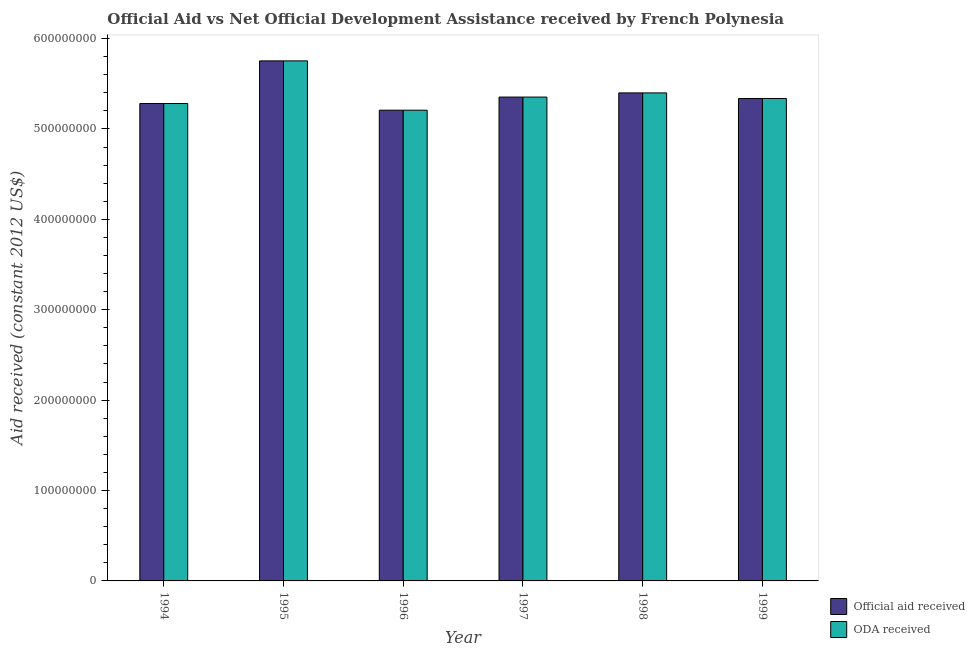How many different coloured bars are there?
Your answer should be very brief. 2. Are the number of bars per tick equal to the number of legend labels?
Your response must be concise. Yes. How many bars are there on the 1st tick from the right?
Your answer should be very brief. 2. What is the label of the 5th group of bars from the left?
Make the answer very short. 1998. What is the oda received in 1994?
Make the answer very short. 5.28e+08. Across all years, what is the maximum oda received?
Provide a succinct answer. 5.75e+08. Across all years, what is the minimum official aid received?
Your answer should be compact. 5.21e+08. In which year was the official aid received minimum?
Provide a succinct answer. 1996. What is the total oda received in the graph?
Offer a very short reply. 3.23e+09. What is the difference between the official aid received in 1998 and that in 1999?
Ensure brevity in your answer.  6.19e+06. What is the difference between the oda received in 1995 and the official aid received in 1998?
Provide a succinct answer. 3.54e+07. What is the average oda received per year?
Make the answer very short. 5.39e+08. In the year 1995, what is the difference between the official aid received and oda received?
Your answer should be very brief. 0. In how many years, is the oda received greater than 80000000 US$?
Offer a terse response. 6. What is the ratio of the oda received in 1998 to that in 1999?
Offer a terse response. 1.01. Is the oda received in 1998 less than that in 1999?
Your response must be concise. No. Is the difference between the official aid received in 1997 and 1999 greater than the difference between the oda received in 1997 and 1999?
Your response must be concise. No. What is the difference between the highest and the second highest official aid received?
Keep it short and to the point. 3.54e+07. What is the difference between the highest and the lowest official aid received?
Give a very brief answer. 5.46e+07. Is the sum of the oda received in 1996 and 1998 greater than the maximum official aid received across all years?
Your response must be concise. Yes. What does the 1st bar from the left in 1999 represents?
Your answer should be compact. Official aid received. What does the 1st bar from the right in 1996 represents?
Ensure brevity in your answer.  ODA received. Are all the bars in the graph horizontal?
Keep it short and to the point. No. How many years are there in the graph?
Your answer should be compact. 6. What is the difference between two consecutive major ticks on the Y-axis?
Offer a very short reply. 1.00e+08. Are the values on the major ticks of Y-axis written in scientific E-notation?
Provide a succinct answer. No. Does the graph contain grids?
Keep it short and to the point. No. How many legend labels are there?
Offer a very short reply. 2. How are the legend labels stacked?
Your response must be concise. Vertical. What is the title of the graph?
Your response must be concise. Official Aid vs Net Official Development Assistance received by French Polynesia . What is the label or title of the Y-axis?
Offer a very short reply. Aid received (constant 2012 US$). What is the Aid received (constant 2012 US$) of Official aid received in 1994?
Your response must be concise. 5.28e+08. What is the Aid received (constant 2012 US$) of ODA received in 1994?
Offer a terse response. 5.28e+08. What is the Aid received (constant 2012 US$) in Official aid received in 1995?
Give a very brief answer. 5.75e+08. What is the Aid received (constant 2012 US$) of ODA received in 1995?
Provide a short and direct response. 5.75e+08. What is the Aid received (constant 2012 US$) of Official aid received in 1996?
Ensure brevity in your answer.  5.21e+08. What is the Aid received (constant 2012 US$) in ODA received in 1996?
Keep it short and to the point. 5.21e+08. What is the Aid received (constant 2012 US$) in Official aid received in 1997?
Your answer should be compact. 5.35e+08. What is the Aid received (constant 2012 US$) in ODA received in 1997?
Provide a succinct answer. 5.35e+08. What is the Aid received (constant 2012 US$) in Official aid received in 1998?
Provide a succinct answer. 5.40e+08. What is the Aid received (constant 2012 US$) of ODA received in 1998?
Provide a short and direct response. 5.40e+08. What is the Aid received (constant 2012 US$) of Official aid received in 1999?
Provide a succinct answer. 5.34e+08. What is the Aid received (constant 2012 US$) of ODA received in 1999?
Offer a very short reply. 5.34e+08. Across all years, what is the maximum Aid received (constant 2012 US$) of Official aid received?
Your answer should be compact. 5.75e+08. Across all years, what is the maximum Aid received (constant 2012 US$) in ODA received?
Offer a very short reply. 5.75e+08. Across all years, what is the minimum Aid received (constant 2012 US$) in Official aid received?
Give a very brief answer. 5.21e+08. Across all years, what is the minimum Aid received (constant 2012 US$) in ODA received?
Your response must be concise. 5.21e+08. What is the total Aid received (constant 2012 US$) in Official aid received in the graph?
Ensure brevity in your answer.  3.23e+09. What is the total Aid received (constant 2012 US$) of ODA received in the graph?
Offer a terse response. 3.23e+09. What is the difference between the Aid received (constant 2012 US$) of Official aid received in 1994 and that in 1995?
Your answer should be very brief. -4.72e+07. What is the difference between the Aid received (constant 2012 US$) in ODA received in 1994 and that in 1995?
Offer a terse response. -4.72e+07. What is the difference between the Aid received (constant 2012 US$) in Official aid received in 1994 and that in 1996?
Your answer should be very brief. 7.39e+06. What is the difference between the Aid received (constant 2012 US$) of ODA received in 1994 and that in 1996?
Provide a short and direct response. 7.39e+06. What is the difference between the Aid received (constant 2012 US$) in Official aid received in 1994 and that in 1997?
Offer a terse response. -7.14e+06. What is the difference between the Aid received (constant 2012 US$) in ODA received in 1994 and that in 1997?
Ensure brevity in your answer.  -7.14e+06. What is the difference between the Aid received (constant 2012 US$) of Official aid received in 1994 and that in 1998?
Ensure brevity in your answer.  -1.18e+07. What is the difference between the Aid received (constant 2012 US$) of ODA received in 1994 and that in 1998?
Provide a short and direct response. -1.18e+07. What is the difference between the Aid received (constant 2012 US$) of Official aid received in 1994 and that in 1999?
Make the answer very short. -5.56e+06. What is the difference between the Aid received (constant 2012 US$) in ODA received in 1994 and that in 1999?
Give a very brief answer. -5.56e+06. What is the difference between the Aid received (constant 2012 US$) of Official aid received in 1995 and that in 1996?
Offer a terse response. 5.46e+07. What is the difference between the Aid received (constant 2012 US$) of ODA received in 1995 and that in 1996?
Provide a succinct answer. 5.46e+07. What is the difference between the Aid received (constant 2012 US$) of Official aid received in 1995 and that in 1997?
Your answer should be very brief. 4.00e+07. What is the difference between the Aid received (constant 2012 US$) of ODA received in 1995 and that in 1997?
Make the answer very short. 4.00e+07. What is the difference between the Aid received (constant 2012 US$) of Official aid received in 1995 and that in 1998?
Offer a very short reply. 3.54e+07. What is the difference between the Aid received (constant 2012 US$) of ODA received in 1995 and that in 1998?
Keep it short and to the point. 3.54e+07. What is the difference between the Aid received (constant 2012 US$) of Official aid received in 1995 and that in 1999?
Give a very brief answer. 4.16e+07. What is the difference between the Aid received (constant 2012 US$) in ODA received in 1995 and that in 1999?
Your answer should be very brief. 4.16e+07. What is the difference between the Aid received (constant 2012 US$) in Official aid received in 1996 and that in 1997?
Keep it short and to the point. -1.45e+07. What is the difference between the Aid received (constant 2012 US$) of ODA received in 1996 and that in 1997?
Provide a succinct answer. -1.45e+07. What is the difference between the Aid received (constant 2012 US$) of Official aid received in 1996 and that in 1998?
Provide a short and direct response. -1.91e+07. What is the difference between the Aid received (constant 2012 US$) of ODA received in 1996 and that in 1998?
Ensure brevity in your answer.  -1.91e+07. What is the difference between the Aid received (constant 2012 US$) of Official aid received in 1996 and that in 1999?
Provide a succinct answer. -1.30e+07. What is the difference between the Aid received (constant 2012 US$) in ODA received in 1996 and that in 1999?
Offer a terse response. -1.30e+07. What is the difference between the Aid received (constant 2012 US$) of Official aid received in 1997 and that in 1998?
Your answer should be very brief. -4.61e+06. What is the difference between the Aid received (constant 2012 US$) in ODA received in 1997 and that in 1998?
Your answer should be compact. -4.61e+06. What is the difference between the Aid received (constant 2012 US$) of Official aid received in 1997 and that in 1999?
Offer a terse response. 1.58e+06. What is the difference between the Aid received (constant 2012 US$) of ODA received in 1997 and that in 1999?
Your response must be concise. 1.58e+06. What is the difference between the Aid received (constant 2012 US$) in Official aid received in 1998 and that in 1999?
Keep it short and to the point. 6.19e+06. What is the difference between the Aid received (constant 2012 US$) in ODA received in 1998 and that in 1999?
Offer a very short reply. 6.19e+06. What is the difference between the Aid received (constant 2012 US$) in Official aid received in 1994 and the Aid received (constant 2012 US$) in ODA received in 1995?
Your answer should be compact. -4.72e+07. What is the difference between the Aid received (constant 2012 US$) in Official aid received in 1994 and the Aid received (constant 2012 US$) in ODA received in 1996?
Ensure brevity in your answer.  7.39e+06. What is the difference between the Aid received (constant 2012 US$) of Official aid received in 1994 and the Aid received (constant 2012 US$) of ODA received in 1997?
Ensure brevity in your answer.  -7.14e+06. What is the difference between the Aid received (constant 2012 US$) of Official aid received in 1994 and the Aid received (constant 2012 US$) of ODA received in 1998?
Give a very brief answer. -1.18e+07. What is the difference between the Aid received (constant 2012 US$) in Official aid received in 1994 and the Aid received (constant 2012 US$) in ODA received in 1999?
Offer a terse response. -5.56e+06. What is the difference between the Aid received (constant 2012 US$) of Official aid received in 1995 and the Aid received (constant 2012 US$) of ODA received in 1996?
Provide a succinct answer. 5.46e+07. What is the difference between the Aid received (constant 2012 US$) in Official aid received in 1995 and the Aid received (constant 2012 US$) in ODA received in 1997?
Give a very brief answer. 4.00e+07. What is the difference between the Aid received (constant 2012 US$) of Official aid received in 1995 and the Aid received (constant 2012 US$) of ODA received in 1998?
Give a very brief answer. 3.54e+07. What is the difference between the Aid received (constant 2012 US$) in Official aid received in 1995 and the Aid received (constant 2012 US$) in ODA received in 1999?
Offer a very short reply. 4.16e+07. What is the difference between the Aid received (constant 2012 US$) of Official aid received in 1996 and the Aid received (constant 2012 US$) of ODA received in 1997?
Offer a very short reply. -1.45e+07. What is the difference between the Aid received (constant 2012 US$) of Official aid received in 1996 and the Aid received (constant 2012 US$) of ODA received in 1998?
Ensure brevity in your answer.  -1.91e+07. What is the difference between the Aid received (constant 2012 US$) in Official aid received in 1996 and the Aid received (constant 2012 US$) in ODA received in 1999?
Offer a very short reply. -1.30e+07. What is the difference between the Aid received (constant 2012 US$) of Official aid received in 1997 and the Aid received (constant 2012 US$) of ODA received in 1998?
Offer a terse response. -4.61e+06. What is the difference between the Aid received (constant 2012 US$) in Official aid received in 1997 and the Aid received (constant 2012 US$) in ODA received in 1999?
Keep it short and to the point. 1.58e+06. What is the difference between the Aid received (constant 2012 US$) in Official aid received in 1998 and the Aid received (constant 2012 US$) in ODA received in 1999?
Your answer should be very brief. 6.19e+06. What is the average Aid received (constant 2012 US$) in Official aid received per year?
Offer a very short reply. 5.39e+08. What is the average Aid received (constant 2012 US$) of ODA received per year?
Provide a short and direct response. 5.39e+08. In the year 1994, what is the difference between the Aid received (constant 2012 US$) of Official aid received and Aid received (constant 2012 US$) of ODA received?
Your answer should be very brief. 0. In the year 1995, what is the difference between the Aid received (constant 2012 US$) of Official aid received and Aid received (constant 2012 US$) of ODA received?
Your response must be concise. 0. In the year 1996, what is the difference between the Aid received (constant 2012 US$) in Official aid received and Aid received (constant 2012 US$) in ODA received?
Give a very brief answer. 0. What is the ratio of the Aid received (constant 2012 US$) of Official aid received in 1994 to that in 1995?
Offer a very short reply. 0.92. What is the ratio of the Aid received (constant 2012 US$) of ODA received in 1994 to that in 1995?
Your answer should be very brief. 0.92. What is the ratio of the Aid received (constant 2012 US$) of Official aid received in 1994 to that in 1996?
Provide a succinct answer. 1.01. What is the ratio of the Aid received (constant 2012 US$) in ODA received in 1994 to that in 1996?
Keep it short and to the point. 1.01. What is the ratio of the Aid received (constant 2012 US$) in Official aid received in 1994 to that in 1997?
Provide a succinct answer. 0.99. What is the ratio of the Aid received (constant 2012 US$) in ODA received in 1994 to that in 1997?
Keep it short and to the point. 0.99. What is the ratio of the Aid received (constant 2012 US$) of Official aid received in 1994 to that in 1998?
Provide a short and direct response. 0.98. What is the ratio of the Aid received (constant 2012 US$) in ODA received in 1994 to that in 1998?
Make the answer very short. 0.98. What is the ratio of the Aid received (constant 2012 US$) of Official aid received in 1994 to that in 1999?
Provide a succinct answer. 0.99. What is the ratio of the Aid received (constant 2012 US$) in ODA received in 1994 to that in 1999?
Your response must be concise. 0.99. What is the ratio of the Aid received (constant 2012 US$) of Official aid received in 1995 to that in 1996?
Your answer should be compact. 1.1. What is the ratio of the Aid received (constant 2012 US$) of ODA received in 1995 to that in 1996?
Provide a short and direct response. 1.1. What is the ratio of the Aid received (constant 2012 US$) in Official aid received in 1995 to that in 1997?
Give a very brief answer. 1.07. What is the ratio of the Aid received (constant 2012 US$) in ODA received in 1995 to that in 1997?
Offer a very short reply. 1.07. What is the ratio of the Aid received (constant 2012 US$) in Official aid received in 1995 to that in 1998?
Your response must be concise. 1.07. What is the ratio of the Aid received (constant 2012 US$) in ODA received in 1995 to that in 1998?
Your answer should be compact. 1.07. What is the ratio of the Aid received (constant 2012 US$) of Official aid received in 1995 to that in 1999?
Make the answer very short. 1.08. What is the ratio of the Aid received (constant 2012 US$) in ODA received in 1995 to that in 1999?
Your answer should be compact. 1.08. What is the ratio of the Aid received (constant 2012 US$) in Official aid received in 1996 to that in 1997?
Give a very brief answer. 0.97. What is the ratio of the Aid received (constant 2012 US$) of ODA received in 1996 to that in 1997?
Your response must be concise. 0.97. What is the ratio of the Aid received (constant 2012 US$) of Official aid received in 1996 to that in 1998?
Provide a succinct answer. 0.96. What is the ratio of the Aid received (constant 2012 US$) in ODA received in 1996 to that in 1998?
Your response must be concise. 0.96. What is the ratio of the Aid received (constant 2012 US$) of Official aid received in 1996 to that in 1999?
Ensure brevity in your answer.  0.98. What is the ratio of the Aid received (constant 2012 US$) in ODA received in 1996 to that in 1999?
Give a very brief answer. 0.98. What is the ratio of the Aid received (constant 2012 US$) in Official aid received in 1997 to that in 1998?
Your answer should be very brief. 0.99. What is the ratio of the Aid received (constant 2012 US$) in ODA received in 1997 to that in 1998?
Your answer should be compact. 0.99. What is the ratio of the Aid received (constant 2012 US$) of ODA received in 1997 to that in 1999?
Your answer should be very brief. 1. What is the ratio of the Aid received (constant 2012 US$) in Official aid received in 1998 to that in 1999?
Ensure brevity in your answer.  1.01. What is the ratio of the Aid received (constant 2012 US$) in ODA received in 1998 to that in 1999?
Provide a short and direct response. 1.01. What is the difference between the highest and the second highest Aid received (constant 2012 US$) of Official aid received?
Your answer should be very brief. 3.54e+07. What is the difference between the highest and the second highest Aid received (constant 2012 US$) in ODA received?
Ensure brevity in your answer.  3.54e+07. What is the difference between the highest and the lowest Aid received (constant 2012 US$) in Official aid received?
Keep it short and to the point. 5.46e+07. What is the difference between the highest and the lowest Aid received (constant 2012 US$) of ODA received?
Offer a very short reply. 5.46e+07. 